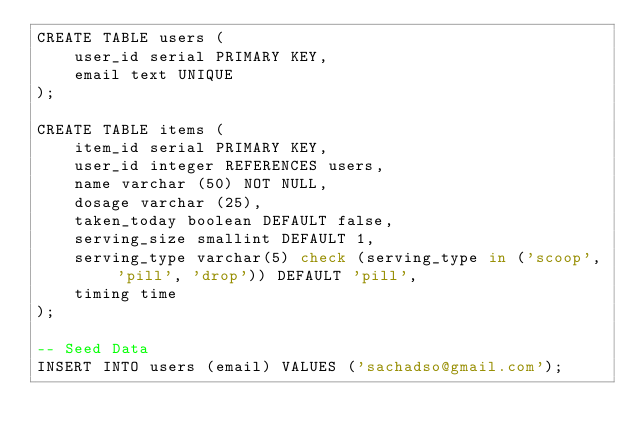Convert code to text. <code><loc_0><loc_0><loc_500><loc_500><_SQL_>CREATE TABLE users (
    user_id serial PRIMARY KEY,
    email text UNIQUE
);

CREATE TABLE items (
    item_id serial PRIMARY KEY, 
    user_id integer REFERENCES users,
    name varchar (50) NOT NULL,
    dosage varchar (25),
    taken_today boolean DEFAULT false,
    serving_size smallint DEFAULT 1,
    serving_type varchar(5) check (serving_type in ('scoop', 'pill', 'drop')) DEFAULT 'pill',
    timing time
);

-- Seed Data
INSERT INTO users (email) VALUES ('sachadso@gmail.com');</code> 